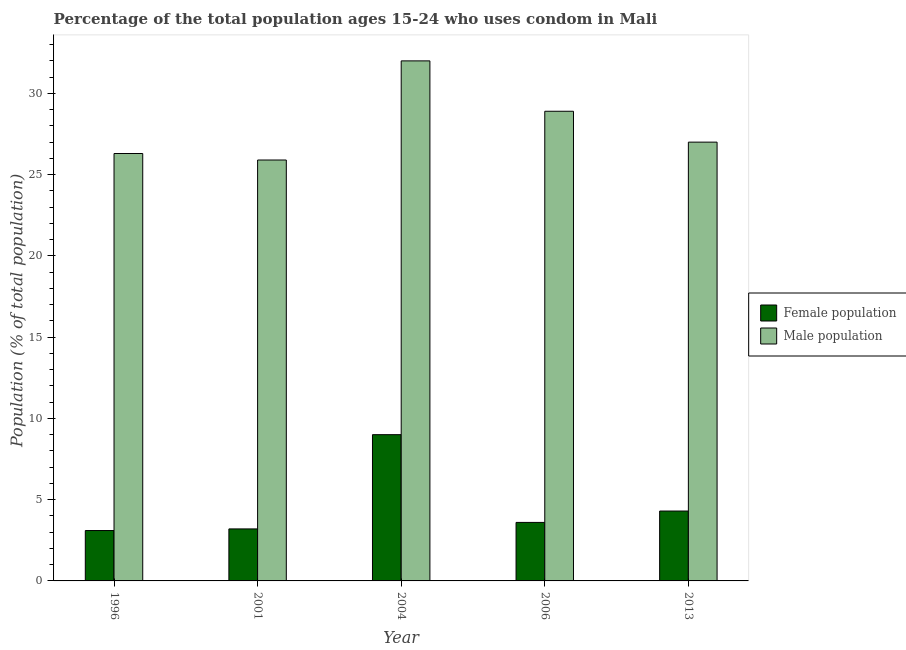Are the number of bars per tick equal to the number of legend labels?
Provide a short and direct response. Yes. Are the number of bars on each tick of the X-axis equal?
Give a very brief answer. Yes. How many bars are there on the 3rd tick from the left?
Provide a short and direct response. 2. How many bars are there on the 2nd tick from the right?
Keep it short and to the point. 2. Across all years, what is the minimum female population?
Offer a terse response. 3.1. What is the total female population in the graph?
Offer a terse response. 23.2. What is the difference between the female population in 1996 and the male population in 2004?
Ensure brevity in your answer.  -5.9. What is the average male population per year?
Your answer should be compact. 28.02. What is the ratio of the female population in 2004 to that in 2013?
Provide a short and direct response. 2.09. Is the difference between the female population in 2001 and 2004 greater than the difference between the male population in 2001 and 2004?
Keep it short and to the point. No. In how many years, is the male population greater than the average male population taken over all years?
Give a very brief answer. 2. Is the sum of the female population in 2004 and 2006 greater than the maximum male population across all years?
Provide a short and direct response. Yes. What does the 1st bar from the left in 1996 represents?
Provide a succinct answer. Female population. What does the 1st bar from the right in 2004 represents?
Your answer should be very brief. Male population. How many bars are there?
Your answer should be very brief. 10. Are the values on the major ticks of Y-axis written in scientific E-notation?
Offer a very short reply. No. Does the graph contain any zero values?
Ensure brevity in your answer.  No. Does the graph contain grids?
Your answer should be very brief. No. How many legend labels are there?
Ensure brevity in your answer.  2. How are the legend labels stacked?
Give a very brief answer. Vertical. What is the title of the graph?
Your response must be concise. Percentage of the total population ages 15-24 who uses condom in Mali. What is the label or title of the X-axis?
Keep it short and to the point. Year. What is the label or title of the Y-axis?
Keep it short and to the point. Population (% of total population) . What is the Population (% of total population)  of Female population in 1996?
Your answer should be very brief. 3.1. What is the Population (% of total population)  in Male population in 1996?
Provide a succinct answer. 26.3. What is the Population (% of total population)  in Male population in 2001?
Provide a succinct answer. 25.9. What is the Population (% of total population)  in Female population in 2004?
Provide a short and direct response. 9. What is the Population (% of total population)  of Male population in 2004?
Provide a short and direct response. 32. What is the Population (% of total population)  in Female population in 2006?
Ensure brevity in your answer.  3.6. What is the Population (% of total population)  of Male population in 2006?
Your answer should be very brief. 28.9. What is the Population (% of total population)  in Female population in 2013?
Give a very brief answer. 4.3. Across all years, what is the maximum Population (% of total population)  of Female population?
Offer a terse response. 9. Across all years, what is the minimum Population (% of total population)  of Female population?
Your response must be concise. 3.1. Across all years, what is the minimum Population (% of total population)  in Male population?
Ensure brevity in your answer.  25.9. What is the total Population (% of total population)  in Female population in the graph?
Ensure brevity in your answer.  23.2. What is the total Population (% of total population)  of Male population in the graph?
Keep it short and to the point. 140.1. What is the difference between the Population (% of total population)  in Male population in 1996 and that in 2001?
Keep it short and to the point. 0.4. What is the difference between the Population (% of total population)  of Female population in 1996 and that in 2004?
Offer a terse response. -5.9. What is the difference between the Population (% of total population)  in Female population in 1996 and that in 2006?
Offer a terse response. -0.5. What is the difference between the Population (% of total population)  in Male population in 1996 and that in 2006?
Give a very brief answer. -2.6. What is the difference between the Population (% of total population)  in Female population in 1996 and that in 2013?
Your response must be concise. -1.2. What is the difference between the Population (% of total population)  of Male population in 2001 and that in 2004?
Your answer should be very brief. -6.1. What is the difference between the Population (% of total population)  of Male population in 2001 and that in 2006?
Your response must be concise. -3. What is the difference between the Population (% of total population)  in Female population in 2001 and that in 2013?
Offer a terse response. -1.1. What is the difference between the Population (% of total population)  in Female population in 2004 and that in 2006?
Make the answer very short. 5.4. What is the difference between the Population (% of total population)  in Male population in 2004 and that in 2006?
Your answer should be compact. 3.1. What is the difference between the Population (% of total population)  in Female population in 2004 and that in 2013?
Your answer should be very brief. 4.7. What is the difference between the Population (% of total population)  in Male population in 2004 and that in 2013?
Your response must be concise. 5. What is the difference between the Population (% of total population)  of Female population in 2006 and that in 2013?
Give a very brief answer. -0.7. What is the difference between the Population (% of total population)  of Female population in 1996 and the Population (% of total population)  of Male population in 2001?
Your answer should be compact. -22.8. What is the difference between the Population (% of total population)  of Female population in 1996 and the Population (% of total population)  of Male population in 2004?
Provide a short and direct response. -28.9. What is the difference between the Population (% of total population)  in Female population in 1996 and the Population (% of total population)  in Male population in 2006?
Provide a succinct answer. -25.8. What is the difference between the Population (% of total population)  of Female population in 1996 and the Population (% of total population)  of Male population in 2013?
Make the answer very short. -23.9. What is the difference between the Population (% of total population)  in Female population in 2001 and the Population (% of total population)  in Male population in 2004?
Provide a succinct answer. -28.8. What is the difference between the Population (% of total population)  in Female population in 2001 and the Population (% of total population)  in Male population in 2006?
Offer a terse response. -25.7. What is the difference between the Population (% of total population)  in Female population in 2001 and the Population (% of total population)  in Male population in 2013?
Your answer should be very brief. -23.8. What is the difference between the Population (% of total population)  in Female population in 2004 and the Population (% of total population)  in Male population in 2006?
Ensure brevity in your answer.  -19.9. What is the difference between the Population (% of total population)  in Female population in 2004 and the Population (% of total population)  in Male population in 2013?
Give a very brief answer. -18. What is the difference between the Population (% of total population)  of Female population in 2006 and the Population (% of total population)  of Male population in 2013?
Ensure brevity in your answer.  -23.4. What is the average Population (% of total population)  in Female population per year?
Offer a very short reply. 4.64. What is the average Population (% of total population)  of Male population per year?
Offer a terse response. 28.02. In the year 1996, what is the difference between the Population (% of total population)  of Female population and Population (% of total population)  of Male population?
Provide a short and direct response. -23.2. In the year 2001, what is the difference between the Population (% of total population)  of Female population and Population (% of total population)  of Male population?
Your answer should be compact. -22.7. In the year 2006, what is the difference between the Population (% of total population)  of Female population and Population (% of total population)  of Male population?
Keep it short and to the point. -25.3. In the year 2013, what is the difference between the Population (% of total population)  of Female population and Population (% of total population)  of Male population?
Offer a terse response. -22.7. What is the ratio of the Population (% of total population)  in Female population in 1996 to that in 2001?
Offer a very short reply. 0.97. What is the ratio of the Population (% of total population)  of Male population in 1996 to that in 2001?
Your answer should be compact. 1.02. What is the ratio of the Population (% of total population)  in Female population in 1996 to that in 2004?
Provide a succinct answer. 0.34. What is the ratio of the Population (% of total population)  of Male population in 1996 to that in 2004?
Provide a short and direct response. 0.82. What is the ratio of the Population (% of total population)  of Female population in 1996 to that in 2006?
Make the answer very short. 0.86. What is the ratio of the Population (% of total population)  in Male population in 1996 to that in 2006?
Your response must be concise. 0.91. What is the ratio of the Population (% of total population)  in Female population in 1996 to that in 2013?
Your answer should be very brief. 0.72. What is the ratio of the Population (% of total population)  of Male population in 1996 to that in 2013?
Keep it short and to the point. 0.97. What is the ratio of the Population (% of total population)  of Female population in 2001 to that in 2004?
Your answer should be very brief. 0.36. What is the ratio of the Population (% of total population)  in Male population in 2001 to that in 2004?
Make the answer very short. 0.81. What is the ratio of the Population (% of total population)  of Male population in 2001 to that in 2006?
Keep it short and to the point. 0.9. What is the ratio of the Population (% of total population)  in Female population in 2001 to that in 2013?
Your answer should be compact. 0.74. What is the ratio of the Population (% of total population)  in Male population in 2001 to that in 2013?
Offer a terse response. 0.96. What is the ratio of the Population (% of total population)  in Female population in 2004 to that in 2006?
Offer a very short reply. 2.5. What is the ratio of the Population (% of total population)  in Male population in 2004 to that in 2006?
Keep it short and to the point. 1.11. What is the ratio of the Population (% of total population)  of Female population in 2004 to that in 2013?
Offer a very short reply. 2.09. What is the ratio of the Population (% of total population)  of Male population in 2004 to that in 2013?
Your answer should be compact. 1.19. What is the ratio of the Population (% of total population)  of Female population in 2006 to that in 2013?
Offer a terse response. 0.84. What is the ratio of the Population (% of total population)  in Male population in 2006 to that in 2013?
Offer a very short reply. 1.07. What is the difference between the highest and the second highest Population (% of total population)  of Male population?
Your answer should be compact. 3.1. What is the difference between the highest and the lowest Population (% of total population)  in Male population?
Provide a short and direct response. 6.1. 